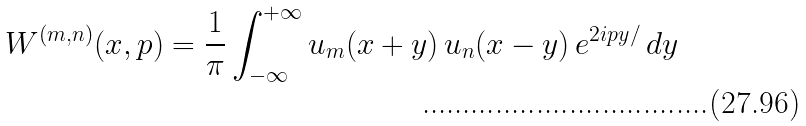<formula> <loc_0><loc_0><loc_500><loc_500>W ^ { ( m , n ) } ( x , p ) = \frac { 1 } { \pi } \int _ { - \infty } ^ { + \infty } u _ { m } ( x + y ) \, u _ { n } ( x - y ) \, e ^ { 2 i p y / } \, d y</formula> 